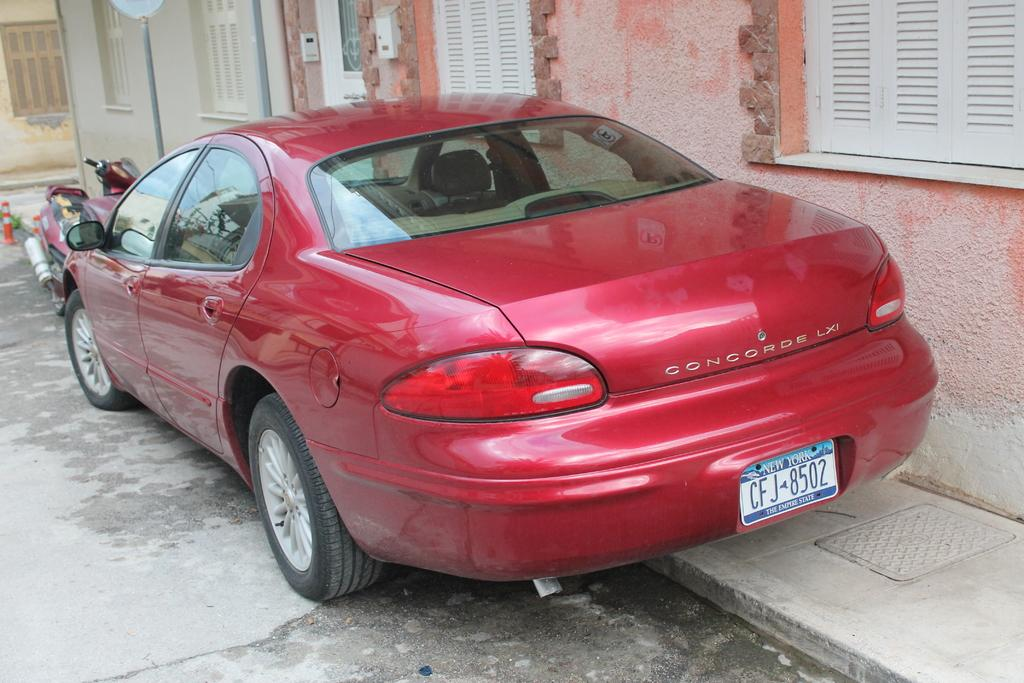<image>
Relay a brief, clear account of the picture shown. A red car is parked on a curb and says Concord LXI on the back. 